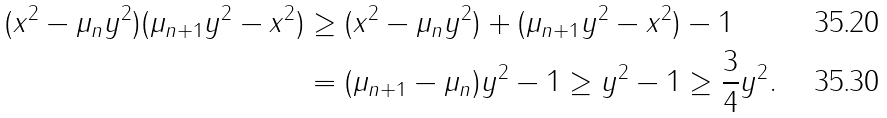Convert formula to latex. <formula><loc_0><loc_0><loc_500><loc_500>( x ^ { 2 } - \mu _ { n } y ^ { 2 } ) ( \mu _ { n + 1 } y ^ { 2 } - x ^ { 2 } ) & \geq ( x ^ { 2 } - \mu _ { n } y ^ { 2 } ) + ( \mu _ { n + 1 } y ^ { 2 } - x ^ { 2 } ) - 1 \\ & = ( \mu _ { n + 1 } - \mu _ { n } ) y ^ { 2 } - 1 \geq y ^ { 2 } - 1 \geq \frac { 3 } { 4 } y ^ { 2 } .</formula> 